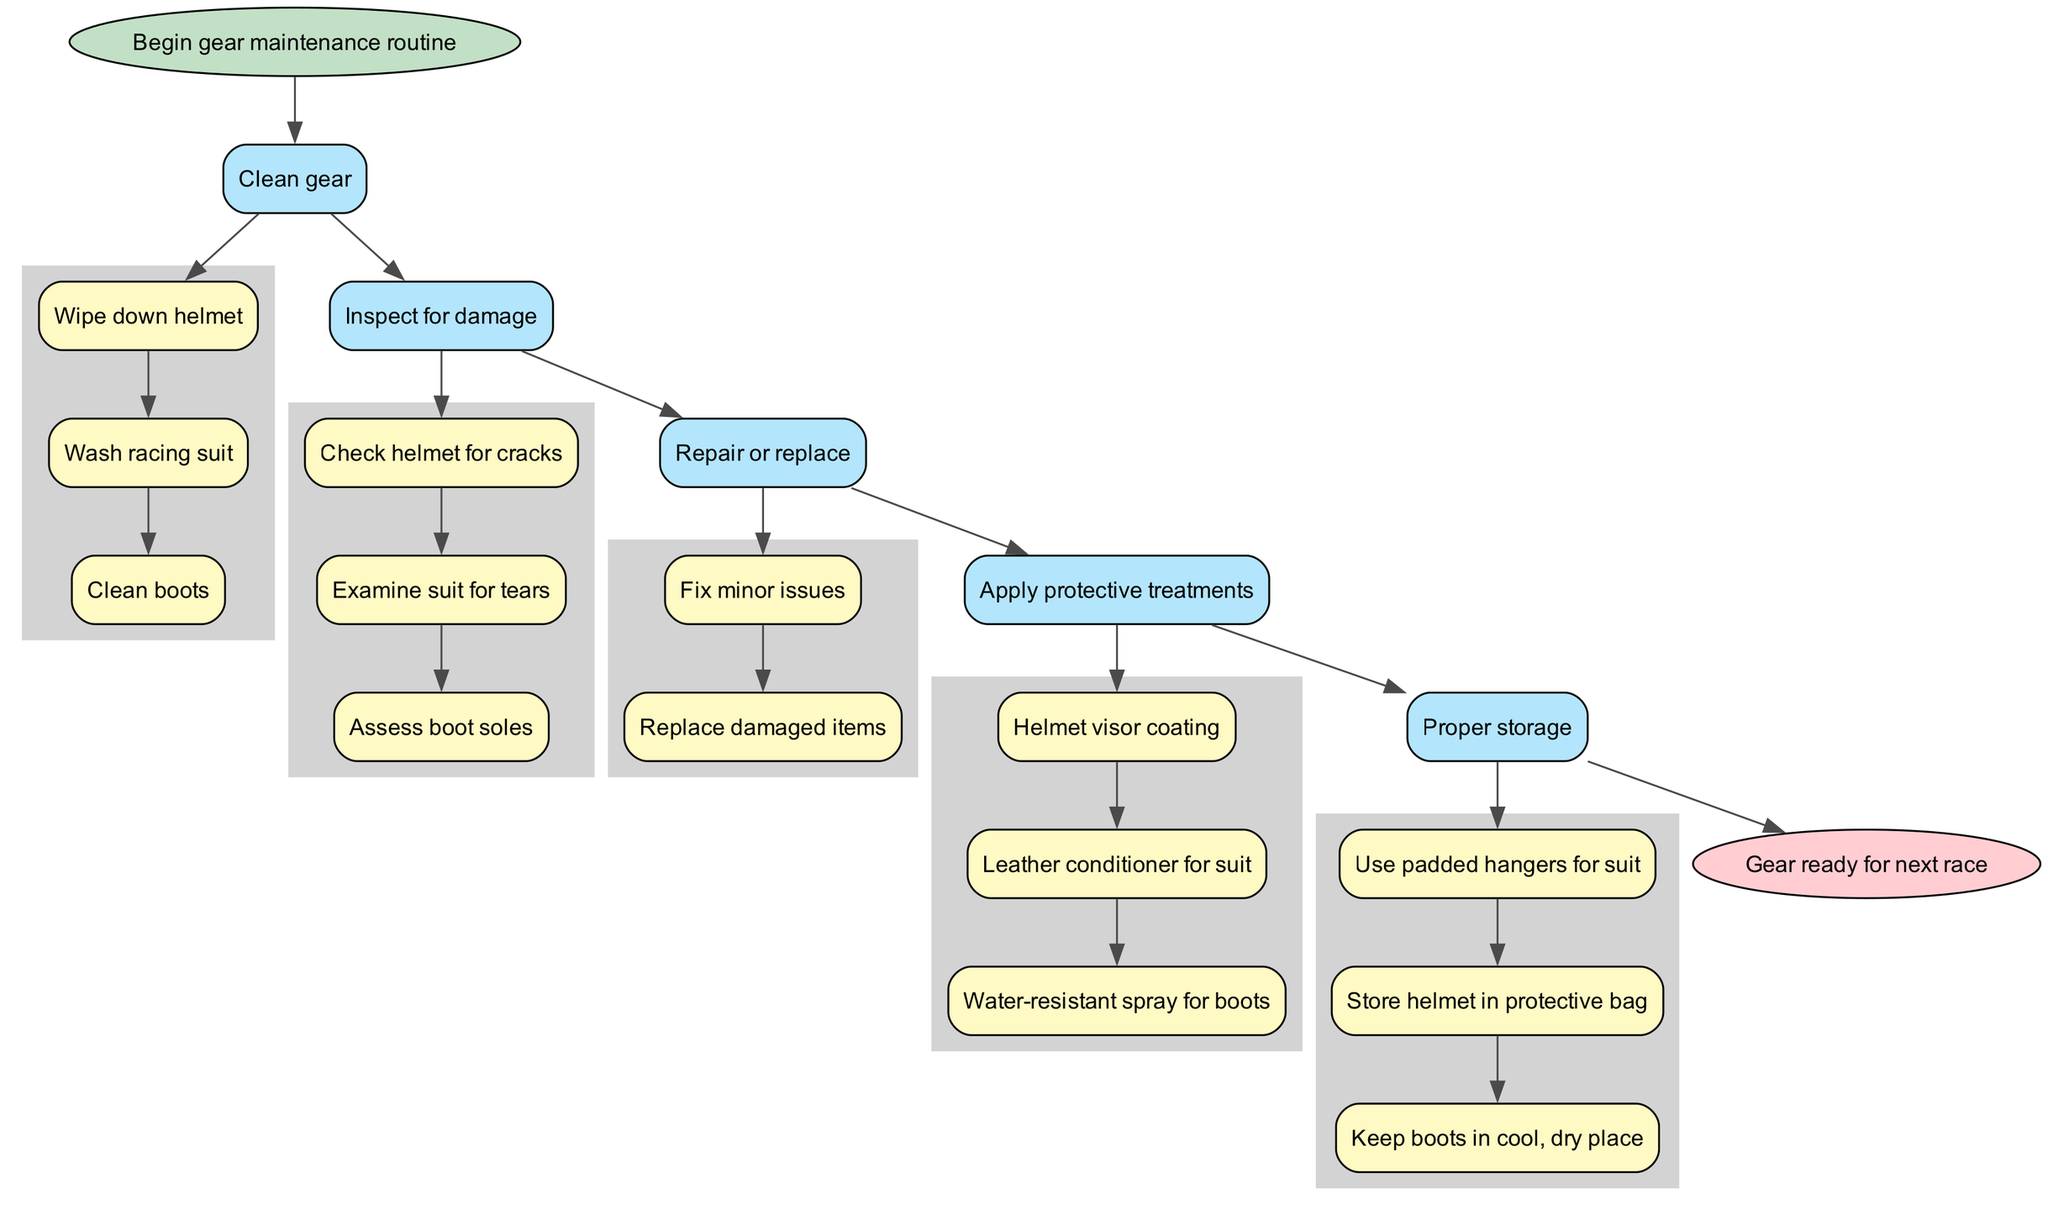What is the first step in the maintenance routine? The first step, according to the flowchart, is "Clean gear." This is the starting point before moving on to the subsequent steps.
Answer: Clean gear How many main steps are in the maintenance process? By counting the main steps listed in the flowchart, there are five distinct steps: Clean gear, Inspect for damage, Repair or replace, Apply protective treatments, and Proper storage.
Answer: 5 What substep is involved in checking damage to the helmet? The flowchart indicates that the specific substep for the helmet check is "Check helmet for cracks." This is a direct inspection of the helmet for any visible damage.
Answer: Check helmet for cracks What should be used for storing the helmet? The diagram specifies that the helmet should be stored "in protective bag." This emphasizes the need for protection to maintain the helmet's integrity.
Answer: in protective bag What comes after "Inspect for damage"? The next step that follows "Inspect for damage" is "Repair or replace." This means that after inspection, one would take actions to fix or substitute any damaged gear found in the previous step.
Answer: Repair or replace Which treatment is recommended for the racing suit? The flowchart indicates the recommended treatment for the racing suit is "Leather conditioner." This substep is crucial for maintaining the material's quality and longevity.
Answer: Leather conditioner How many substeps are there under "Apply protective treatments"? Under "Apply protective treatments," there are three substeps mentioned in the flowchart: "Helmet visor coating," "Leather conditioner for suit," and "Water-resistant spray for boots." Therefore, the total number of substeps is three.
Answer: 3 Which step involves assessing the boot soles? The step that involves evaluating the boot soles is "Inspect for damage." This step specifically includes assessing the soles to ensure they are still functional and safe for racing.
Answer: Inspect for damage What should be used for keeping the boots during storage? The flowchart specifies that boots should be kept "in cool, dry place." This highlights the importance of environmental conditions for the boots' preservation.
Answer: in cool, dry place 